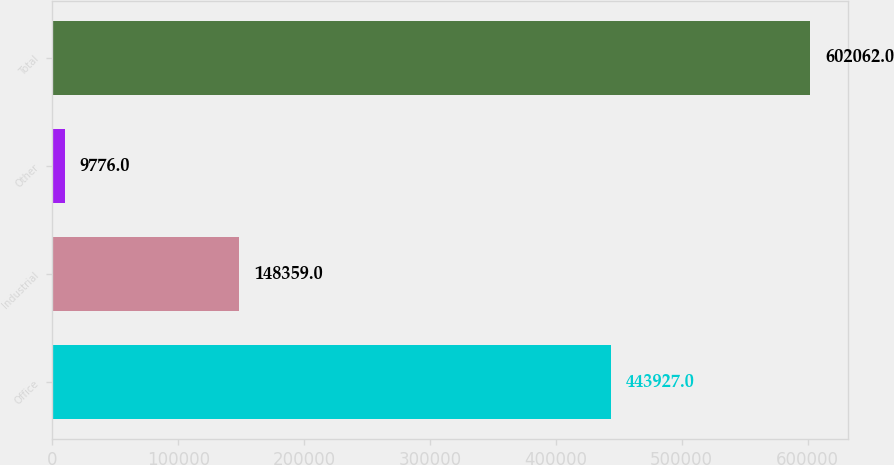<chart> <loc_0><loc_0><loc_500><loc_500><bar_chart><fcel>Office<fcel>Industrial<fcel>Other<fcel>Total<nl><fcel>443927<fcel>148359<fcel>9776<fcel>602062<nl></chart> 